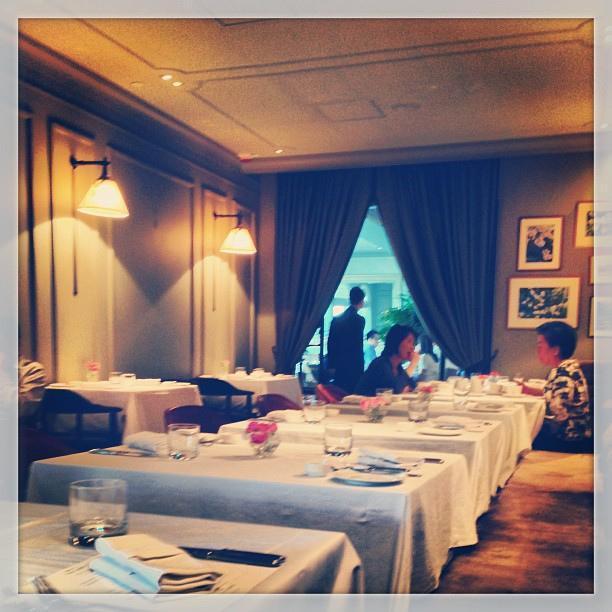How many wall lamps in the room?
Give a very brief answer. 2. How many dining tables are in the picture?
Give a very brief answer. 6. How many chairs are there?
Give a very brief answer. 2. How many people are in the photo?
Give a very brief answer. 3. 